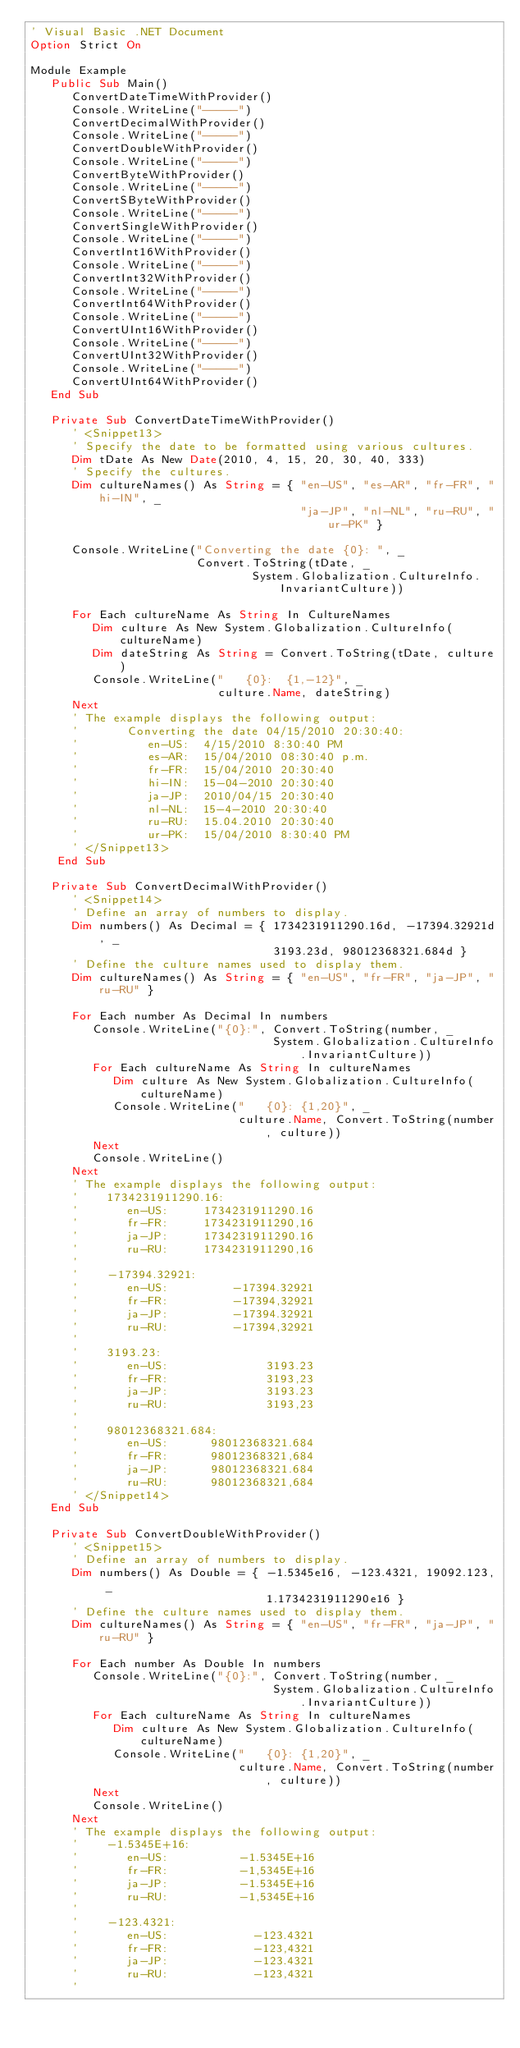<code> <loc_0><loc_0><loc_500><loc_500><_VisualBasic_>' Visual Basic .NET Document
Option Strict On

Module Example
   Public Sub Main()
      ConvertDateTimeWithProvider()
      Console.WriteLine("-----")
      ConvertDecimalWithProvider()
      Console.WriteLine("-----")
      ConvertDoubleWithProvider()
      Console.WriteLine("-----")
      ConvertByteWithProvider()
      Console.WriteLine("-----")
      ConvertSByteWithProvider()
      Console.WriteLine("-----")
      ConvertSingleWithProvider()
      Console.WriteLine("-----")
      ConvertInt16WithProvider()
      Console.WriteLine("-----")
      ConvertInt32WithProvider()
      Console.WriteLine("-----")
      ConvertInt64WithProvider()
      Console.WriteLine("-----")
      ConvertUInt16WithProvider()
      Console.WriteLine("-----")
      ConvertUInt32WithProvider()
      Console.WriteLine("-----")
      ConvertUInt64WithProvider()
   End Sub
   
   Private Sub ConvertDateTimeWithProvider()
      ' <Snippet13>
      ' Specify the date to be formatted using various cultures.
      Dim tDate As New Date(2010, 4, 15, 20, 30, 40, 333)
      ' Specify the cultures.
      Dim cultureNames() As String = { "en-US", "es-AR", "fr-FR", "hi-IN", _
                                       "ja-JP", "nl-NL", "ru-RU", "ur-PK" }
      
      Console.WriteLine("Converting the date {0}: ", _
                        Convert.ToString(tDate, _
                                System.Globalization.CultureInfo.InvariantCulture))

      For Each cultureName As String In CultureNames
         Dim culture As New System.Globalization.CultureInfo(cultureName)
         Dim dateString As String = Convert.ToString(tDate, culture)
         Console.WriteLine("   {0}:  {1,-12}", _
                           culture.Name, dateString)
      Next             
      ' The example displays the following output:
      '       Converting the date 04/15/2010 20:30:40:
      '          en-US:  4/15/2010 8:30:40 PM
      '          es-AR:  15/04/2010 08:30:40 p.m.
      '          fr-FR:  15/04/2010 20:30:40
      '          hi-IN:  15-04-2010 20:30:40
      '          ja-JP:  2010/04/15 20:30:40
      '          nl-NL:  15-4-2010 20:30:40
      '          ru-RU:  15.04.2010 20:30:40
      '          ur-PK:  15/04/2010 8:30:40 PM      
      ' </Snippet13>
    End Sub 

   Private Sub ConvertDecimalWithProvider()
      ' <Snippet14>
      ' Define an array of numbers to display.
      Dim numbers() As Decimal = { 1734231911290.16d, -17394.32921d, _
                                   3193.23d, 98012368321.684d }
      ' Define the culture names used to display them.
      Dim cultureNames() As String = { "en-US", "fr-FR", "ja-JP", "ru-RU" }
      
      For Each number As Decimal In numbers
         Console.WriteLine("{0}:", Convert.ToString(number, _
                                   System.Globalization.CultureInfo.InvariantCulture))
         For Each cultureName As String In cultureNames
            Dim culture As New System.Globalization.CultureInfo(cultureName)
            Console.WriteLine("   {0}: {1,20}", _
                              culture.Name, Convert.ToString(number, culture))
         Next
         Console.WriteLine()
      Next   
      ' The example displays the following output:
      '    1734231911290.16:
      '       en-US:     1734231911290.16
      '       fr-FR:     1734231911290,16
      '       ja-JP:     1734231911290.16
      '       ru-RU:     1734231911290,16
      '    
      '    -17394.32921:
      '       en-US:         -17394.32921
      '       fr-FR:         -17394,32921
      '       ja-JP:         -17394.32921
      '       ru-RU:         -17394,32921
      '    
      '    3193.23:
      '       en-US:              3193.23
      '       fr-FR:              3193,23
      '       ja-JP:              3193.23
      '       ru-RU:              3193,23
      '    
      '    98012368321.684:
      '       en-US:      98012368321.684
      '       fr-FR:      98012368321,684
      '       ja-JP:      98012368321.684
      '       ru-RU:      98012368321,684
      ' </Snippet14>
   End Sub
   
   Private Sub ConvertDoubleWithProvider()
      ' <Snippet15>
      ' Define an array of numbers to display.
      Dim numbers() As Double = { -1.5345e16, -123.4321, 19092.123, _
                                  1.1734231911290e16 }
      ' Define the culture names used to display them.
      Dim cultureNames() As String = { "en-US", "fr-FR", "ja-JP", "ru-RU" }
      
      For Each number As Double In numbers
         Console.WriteLine("{0}:", Convert.ToString(number, _
                                   System.Globalization.CultureInfo.InvariantCulture))
         For Each cultureName As String In cultureNames
            Dim culture As New System.Globalization.CultureInfo(cultureName)
            Console.WriteLine("   {0}: {1,20}", _
                              culture.Name, Convert.ToString(number, culture))
         Next
         Console.WriteLine()
      Next   
      ' The example displays the following output:
      '    -1.5345E+16:
      '       en-US:          -1.5345E+16
      '       fr-FR:          -1,5345E+16
      '       ja-JP:          -1.5345E+16
      '       ru-RU:          -1,5345E+16
      '    
      '    -123.4321:
      '       en-US:            -123.4321
      '       fr-FR:            -123,4321
      '       ja-JP:            -123.4321
      '       ru-RU:            -123,4321
      '    </code> 